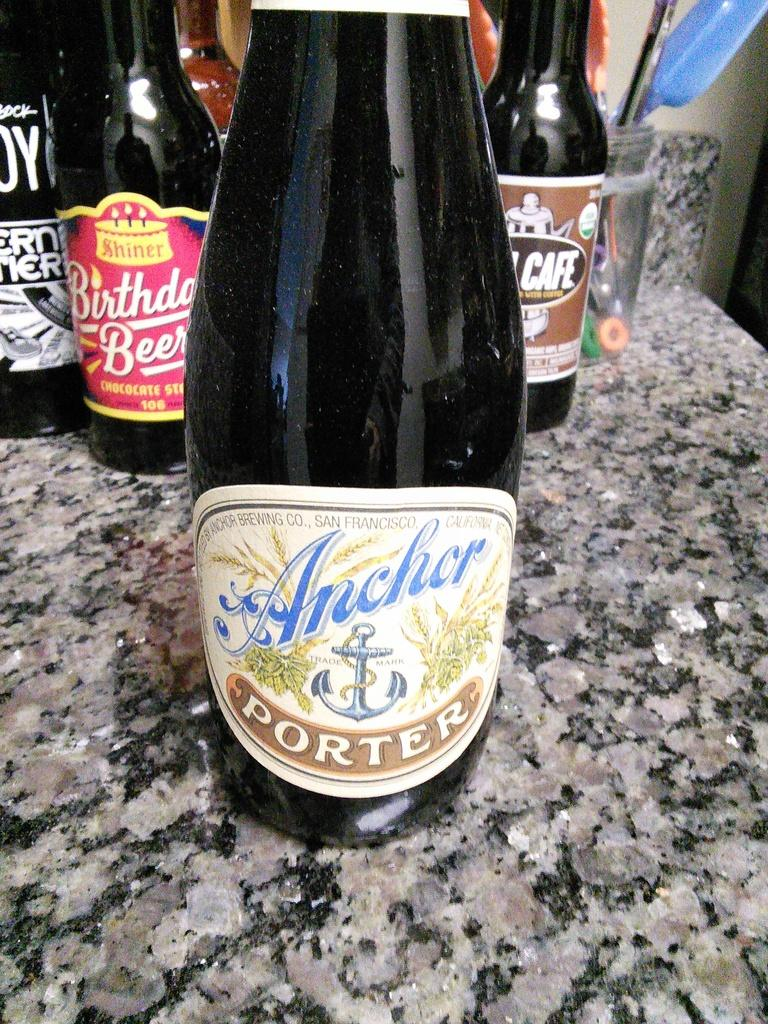<image>
Summarize the visual content of the image. A bottle of Anchor Porter sits on a stone kitchen counter. 